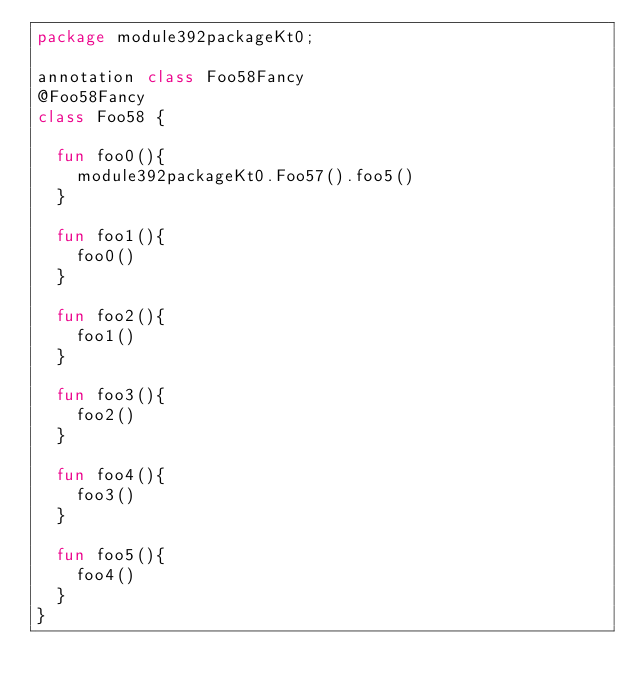Convert code to text. <code><loc_0><loc_0><loc_500><loc_500><_Kotlin_>package module392packageKt0;

annotation class Foo58Fancy
@Foo58Fancy
class Foo58 {

  fun foo0(){
    module392packageKt0.Foo57().foo5()
  }

  fun foo1(){
    foo0()
  }

  fun foo2(){
    foo1()
  }

  fun foo3(){
    foo2()
  }

  fun foo4(){
    foo3()
  }

  fun foo5(){
    foo4()
  }
}</code> 